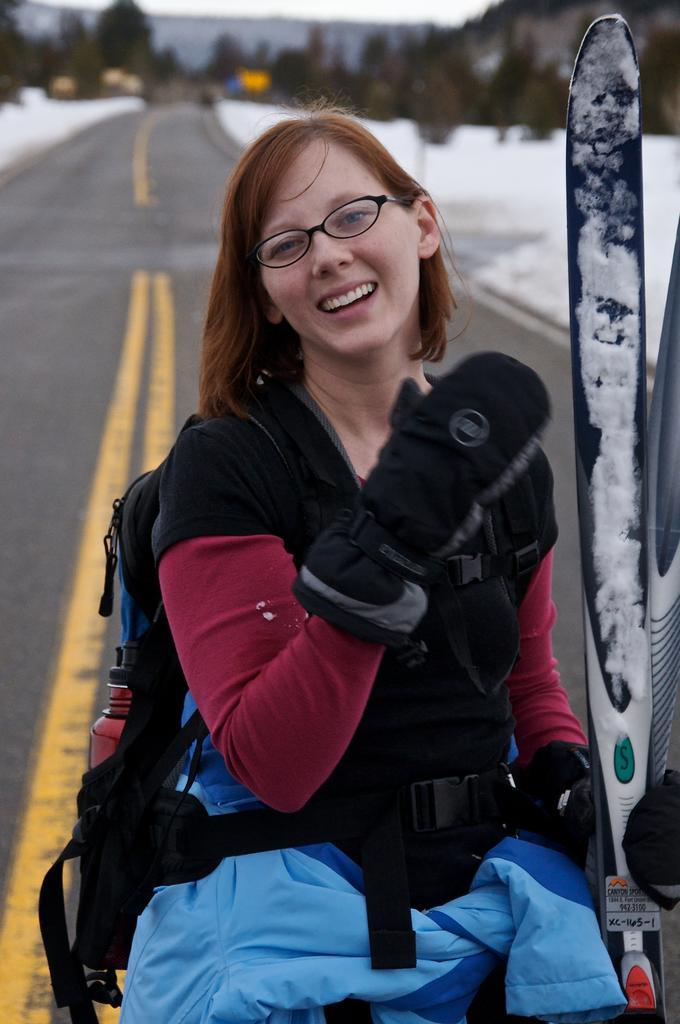How would you summarize this image in a sentence or two? As we can see in the image there is a woman wearing bag and holding a surfboard. In the background there are trees and the background is little blur. 